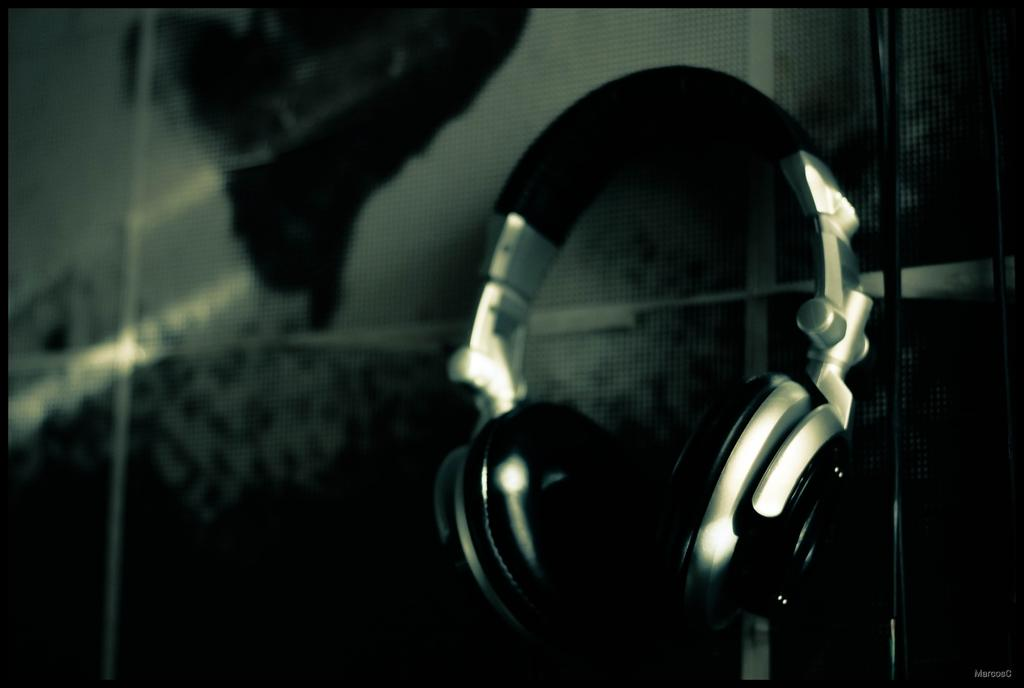What type of equipment can be seen in the image? There are headsets in the image. What can be observed about the background of the image? The background of the image is dark. What color is the love that is present in the image? There is no mention of love in the image, and therefore no color can be assigned to it. 